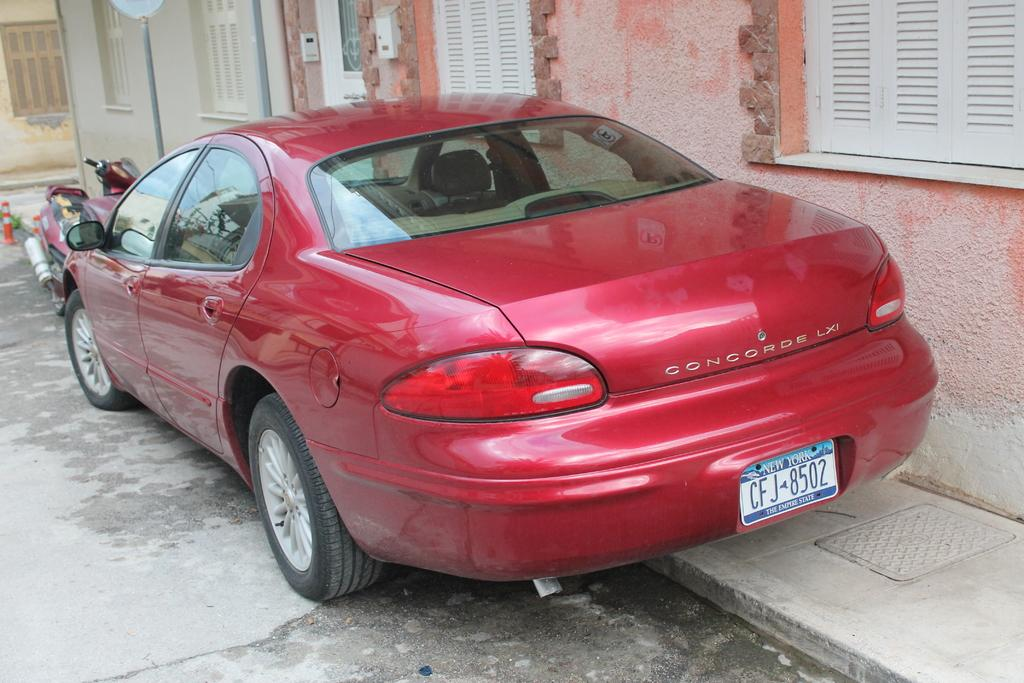<image>
Provide a brief description of the given image. A red Concorde Lxi car parked on the side of the road. 